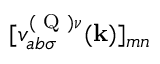Convert formula to latex. <formula><loc_0><loc_0><loc_500><loc_500>[ v _ { a b \sigma } ^ { ( Q ) \nu } ( k ) ] _ { m n }</formula> 